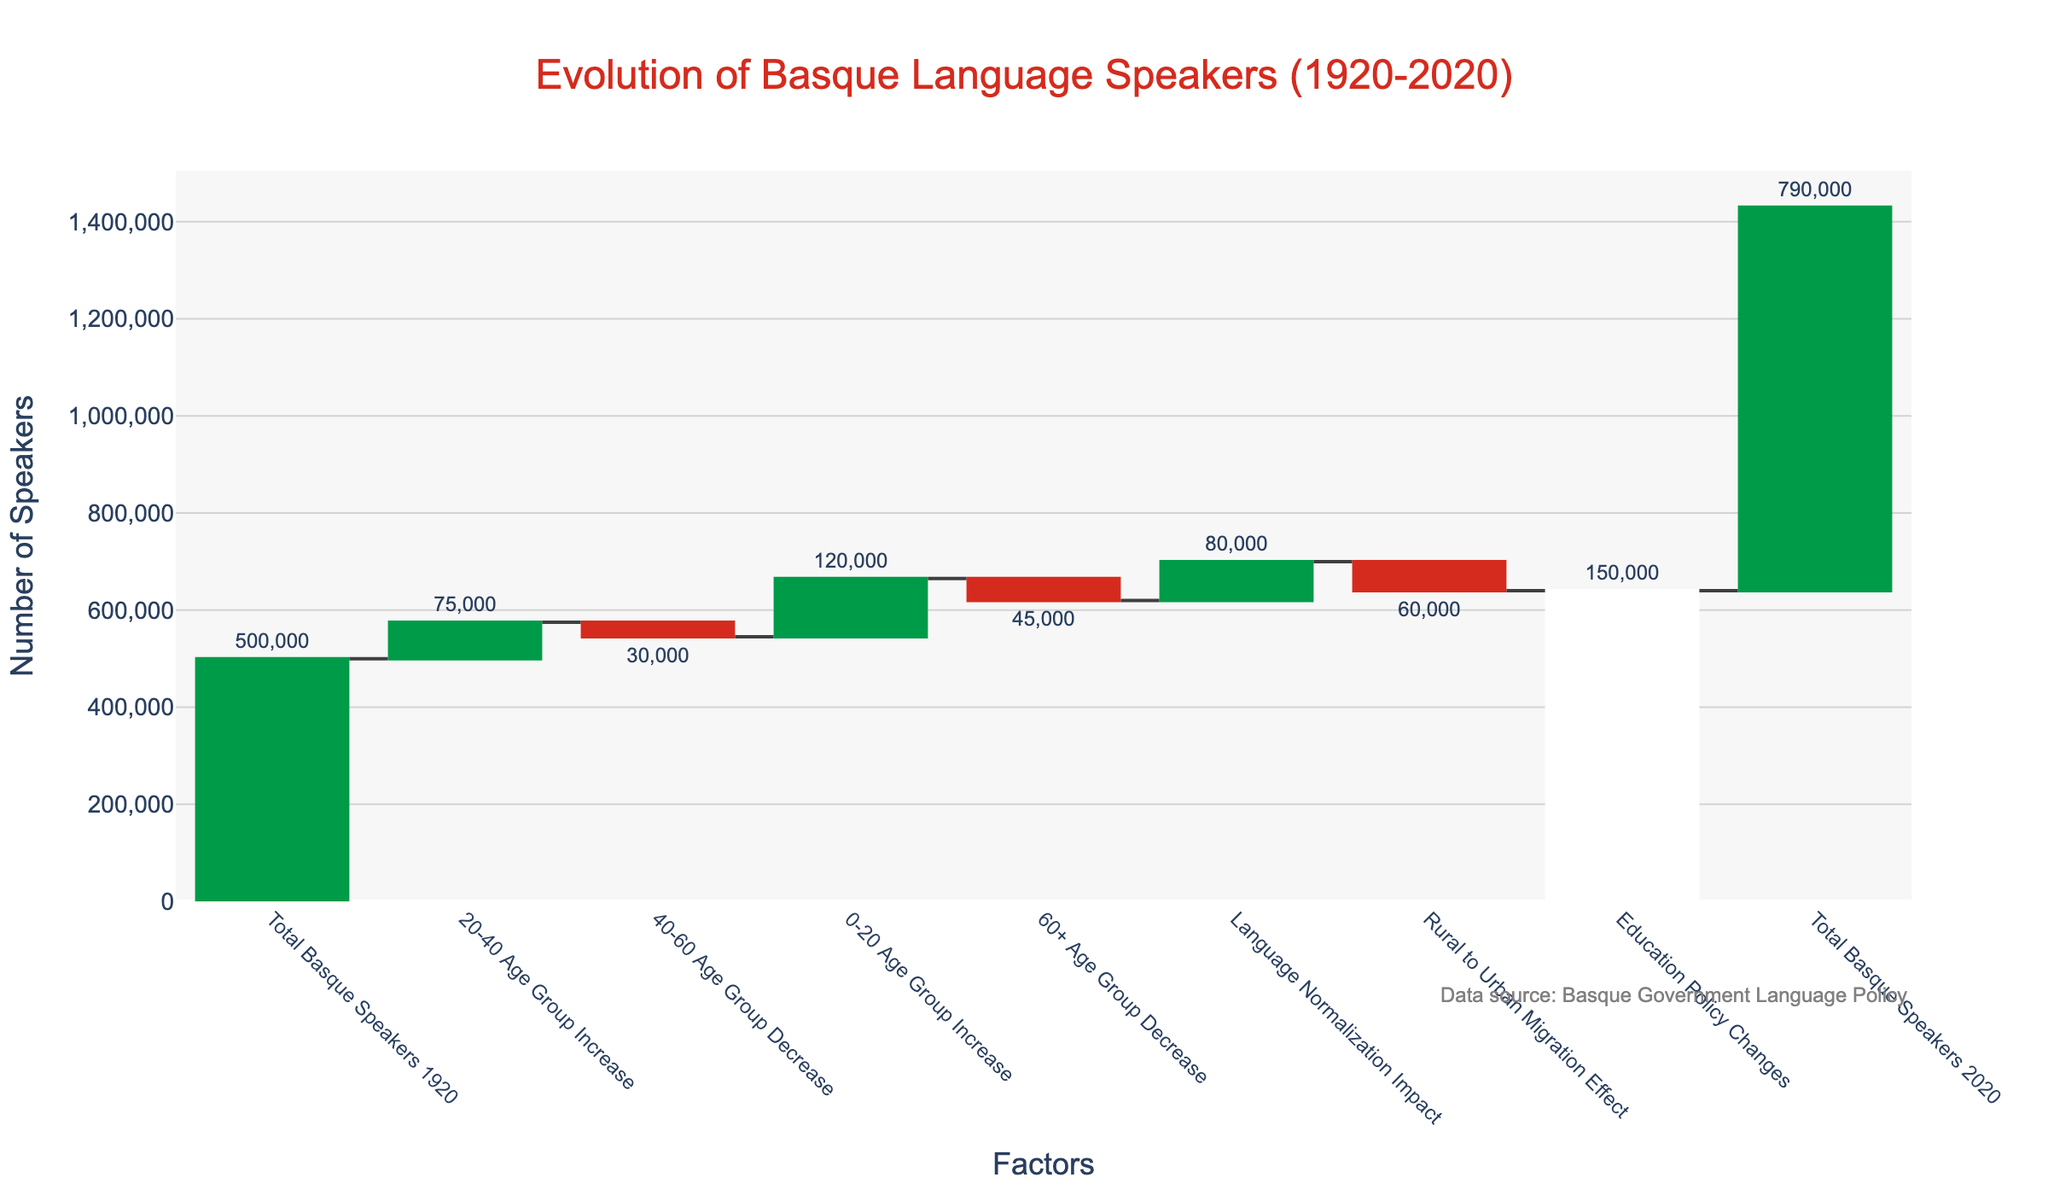What is the title of the chart? The title of the chart is typically found at the top and is written in a larger font. In this chart, we see "Evolution of Basque Language Speakers (1920-2020)" prominently displayed.
Answer: Evolution of Basque Language Speakers (1920-2020) How many data points are there in the chart? By counting the bars in the waterfall chart, we can determine the number of data points. This chart has 9 data points, corresponding to categories such as "Total Basque Speakers 1920", age group changes, "Language Normalization Impact", and more.
Answer: 9 What is the impact of rural to urban migration on the number of Basque speakers? We look at the bar labeled "Rural to Urban Migration Effect" and see a decrease in value. The exact value is shown outside the bar, which is -60,000.
Answer: -60,000 Which age group experienced the largest increase in Basque speakers? By comparing the increase values within the age groups, the "0-20 Age Group Increase" has the highest value of 120,000 as indicated by the length and label of the bar.
Answer: 0-20 Age Group What was the overall impact of education policy changes? The bar labeled "Education Policy Changes" shows an increase, and the value displayed outside this bar is 150,000.
Answer: 150,000 How did Basque language normalization affect the number of speakers? The bar labeled "Language Normalization Impact" indicates an increase, and the value associated with this impact is 80,000.
Answer: 80,000 What is the net effect of the 40-60 age group and 60+ age group changes? The 40-60 Age Group shows a decrease of -30,000, and the 60+ Age Group shows a decrease of -45,000. Adding these changes gives us -30,000 + (-45,000) = -75,000.
Answer: -75,000 Comparing 1920 and 2020, how many more Basque speakers are there today? The 2020 total is 790,000, and the 1920 total is 500,000. Subtracting these gives us 790,000 - 500,000 = 290,000.
Answer: 290,000 What is the combined effect of the increases in the 0-20 and 20-40 age groups? The increase in the 0-20 age group is 120,000, and in the 20-40 age group is 75,000. Adding them together gives us 120,000 + 75,000 = 195,000.
Answer: 195,000 How did the 20-40 and 40-60 age groups together affect the number of speakers? The 20-40 age group increased by 75,000, while the 40-60 age group decreased by 30,000. The net effect is 75,000 - 30,000 = 45,000.
Answer: 45,000 